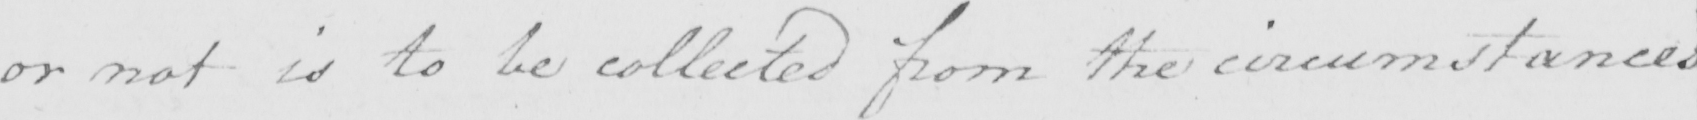Please transcribe the handwritten text in this image. or not is to be collected from the circumstances 